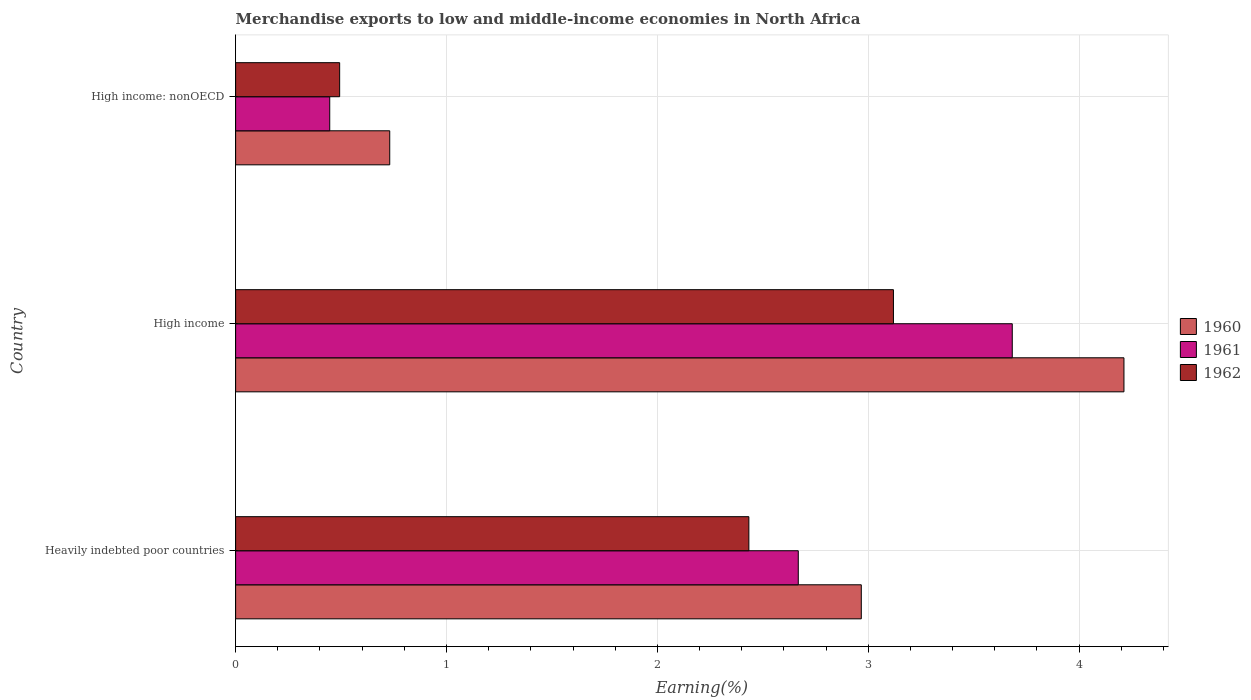How many different coloured bars are there?
Provide a succinct answer. 3. Are the number of bars on each tick of the Y-axis equal?
Offer a terse response. Yes. How many bars are there on the 3rd tick from the top?
Provide a succinct answer. 3. What is the label of the 2nd group of bars from the top?
Provide a short and direct response. High income. In how many cases, is the number of bars for a given country not equal to the number of legend labels?
Provide a succinct answer. 0. What is the percentage of amount earned from merchandise exports in 1962 in High income?
Your answer should be very brief. 3.12. Across all countries, what is the maximum percentage of amount earned from merchandise exports in 1960?
Your response must be concise. 4.21. Across all countries, what is the minimum percentage of amount earned from merchandise exports in 1962?
Your answer should be compact. 0.49. In which country was the percentage of amount earned from merchandise exports in 1960 maximum?
Provide a short and direct response. High income. In which country was the percentage of amount earned from merchandise exports in 1962 minimum?
Keep it short and to the point. High income: nonOECD. What is the total percentage of amount earned from merchandise exports in 1962 in the graph?
Your answer should be compact. 6.05. What is the difference between the percentage of amount earned from merchandise exports in 1960 in Heavily indebted poor countries and that in High income?
Provide a succinct answer. -1.25. What is the difference between the percentage of amount earned from merchandise exports in 1960 in High income and the percentage of amount earned from merchandise exports in 1961 in High income: nonOECD?
Your answer should be very brief. 3.77. What is the average percentage of amount earned from merchandise exports in 1961 per country?
Keep it short and to the point. 2.27. What is the difference between the percentage of amount earned from merchandise exports in 1960 and percentage of amount earned from merchandise exports in 1962 in High income: nonOECD?
Your answer should be very brief. 0.24. In how many countries, is the percentage of amount earned from merchandise exports in 1962 greater than 3.8 %?
Make the answer very short. 0. What is the ratio of the percentage of amount earned from merchandise exports in 1961 in High income to that in High income: nonOECD?
Give a very brief answer. 8.25. Is the percentage of amount earned from merchandise exports in 1961 in High income less than that in High income: nonOECD?
Your answer should be compact. No. What is the difference between the highest and the second highest percentage of amount earned from merchandise exports in 1962?
Your response must be concise. 0.69. What is the difference between the highest and the lowest percentage of amount earned from merchandise exports in 1960?
Provide a short and direct response. 3.48. Is the sum of the percentage of amount earned from merchandise exports in 1960 in High income and High income: nonOECD greater than the maximum percentage of amount earned from merchandise exports in 1962 across all countries?
Provide a succinct answer. Yes. What does the 2nd bar from the bottom in High income represents?
Make the answer very short. 1961. Is it the case that in every country, the sum of the percentage of amount earned from merchandise exports in 1960 and percentage of amount earned from merchandise exports in 1961 is greater than the percentage of amount earned from merchandise exports in 1962?
Give a very brief answer. Yes. How many bars are there?
Ensure brevity in your answer.  9. What is the difference between two consecutive major ticks on the X-axis?
Your answer should be compact. 1. Does the graph contain grids?
Your response must be concise. Yes. Where does the legend appear in the graph?
Keep it short and to the point. Center right. What is the title of the graph?
Provide a short and direct response. Merchandise exports to low and middle-income economies in North Africa. Does "1982" appear as one of the legend labels in the graph?
Give a very brief answer. No. What is the label or title of the X-axis?
Offer a very short reply. Earning(%). What is the label or title of the Y-axis?
Keep it short and to the point. Country. What is the Earning(%) in 1960 in Heavily indebted poor countries?
Provide a short and direct response. 2.97. What is the Earning(%) of 1961 in Heavily indebted poor countries?
Give a very brief answer. 2.67. What is the Earning(%) in 1962 in Heavily indebted poor countries?
Provide a succinct answer. 2.43. What is the Earning(%) of 1960 in High income?
Make the answer very short. 4.21. What is the Earning(%) of 1961 in High income?
Offer a very short reply. 3.68. What is the Earning(%) of 1962 in High income?
Your answer should be compact. 3.12. What is the Earning(%) of 1960 in High income: nonOECD?
Provide a succinct answer. 0.73. What is the Earning(%) of 1961 in High income: nonOECD?
Ensure brevity in your answer.  0.45. What is the Earning(%) in 1962 in High income: nonOECD?
Provide a succinct answer. 0.49. Across all countries, what is the maximum Earning(%) in 1960?
Ensure brevity in your answer.  4.21. Across all countries, what is the maximum Earning(%) in 1961?
Your answer should be compact. 3.68. Across all countries, what is the maximum Earning(%) of 1962?
Your response must be concise. 3.12. Across all countries, what is the minimum Earning(%) in 1960?
Give a very brief answer. 0.73. Across all countries, what is the minimum Earning(%) of 1961?
Ensure brevity in your answer.  0.45. Across all countries, what is the minimum Earning(%) of 1962?
Give a very brief answer. 0.49. What is the total Earning(%) of 1960 in the graph?
Provide a succinct answer. 7.91. What is the total Earning(%) in 1961 in the graph?
Your answer should be compact. 6.8. What is the total Earning(%) in 1962 in the graph?
Provide a short and direct response. 6.05. What is the difference between the Earning(%) of 1960 in Heavily indebted poor countries and that in High income?
Provide a short and direct response. -1.25. What is the difference between the Earning(%) of 1961 in Heavily indebted poor countries and that in High income?
Make the answer very short. -1.01. What is the difference between the Earning(%) of 1962 in Heavily indebted poor countries and that in High income?
Provide a succinct answer. -0.69. What is the difference between the Earning(%) of 1960 in Heavily indebted poor countries and that in High income: nonOECD?
Ensure brevity in your answer.  2.24. What is the difference between the Earning(%) of 1961 in Heavily indebted poor countries and that in High income: nonOECD?
Keep it short and to the point. 2.22. What is the difference between the Earning(%) of 1962 in Heavily indebted poor countries and that in High income: nonOECD?
Give a very brief answer. 1.94. What is the difference between the Earning(%) of 1960 in High income and that in High income: nonOECD?
Your answer should be compact. 3.48. What is the difference between the Earning(%) in 1961 in High income and that in High income: nonOECD?
Your answer should be very brief. 3.24. What is the difference between the Earning(%) of 1962 in High income and that in High income: nonOECD?
Your answer should be very brief. 2.63. What is the difference between the Earning(%) of 1960 in Heavily indebted poor countries and the Earning(%) of 1961 in High income?
Your answer should be very brief. -0.72. What is the difference between the Earning(%) of 1960 in Heavily indebted poor countries and the Earning(%) of 1962 in High income?
Your answer should be compact. -0.15. What is the difference between the Earning(%) of 1961 in Heavily indebted poor countries and the Earning(%) of 1962 in High income?
Ensure brevity in your answer.  -0.45. What is the difference between the Earning(%) of 1960 in Heavily indebted poor countries and the Earning(%) of 1961 in High income: nonOECD?
Your answer should be compact. 2.52. What is the difference between the Earning(%) in 1960 in Heavily indebted poor countries and the Earning(%) in 1962 in High income: nonOECD?
Offer a very short reply. 2.47. What is the difference between the Earning(%) in 1961 in Heavily indebted poor countries and the Earning(%) in 1962 in High income: nonOECD?
Your answer should be very brief. 2.17. What is the difference between the Earning(%) in 1960 in High income and the Earning(%) in 1961 in High income: nonOECD?
Offer a very short reply. 3.77. What is the difference between the Earning(%) in 1960 in High income and the Earning(%) in 1962 in High income: nonOECD?
Your response must be concise. 3.72. What is the difference between the Earning(%) in 1961 in High income and the Earning(%) in 1962 in High income: nonOECD?
Provide a succinct answer. 3.19. What is the average Earning(%) in 1960 per country?
Give a very brief answer. 2.64. What is the average Earning(%) in 1961 per country?
Make the answer very short. 2.27. What is the average Earning(%) in 1962 per country?
Give a very brief answer. 2.02. What is the difference between the Earning(%) of 1960 and Earning(%) of 1961 in Heavily indebted poor countries?
Offer a terse response. 0.3. What is the difference between the Earning(%) of 1960 and Earning(%) of 1962 in Heavily indebted poor countries?
Offer a terse response. 0.53. What is the difference between the Earning(%) of 1961 and Earning(%) of 1962 in Heavily indebted poor countries?
Provide a short and direct response. 0.23. What is the difference between the Earning(%) of 1960 and Earning(%) of 1961 in High income?
Your answer should be compact. 0.53. What is the difference between the Earning(%) in 1960 and Earning(%) in 1962 in High income?
Make the answer very short. 1.09. What is the difference between the Earning(%) in 1961 and Earning(%) in 1962 in High income?
Make the answer very short. 0.56. What is the difference between the Earning(%) in 1960 and Earning(%) in 1961 in High income: nonOECD?
Ensure brevity in your answer.  0.28. What is the difference between the Earning(%) in 1960 and Earning(%) in 1962 in High income: nonOECD?
Ensure brevity in your answer.  0.24. What is the difference between the Earning(%) of 1961 and Earning(%) of 1962 in High income: nonOECD?
Give a very brief answer. -0.05. What is the ratio of the Earning(%) in 1960 in Heavily indebted poor countries to that in High income?
Provide a short and direct response. 0.7. What is the ratio of the Earning(%) of 1961 in Heavily indebted poor countries to that in High income?
Your answer should be very brief. 0.72. What is the ratio of the Earning(%) of 1962 in Heavily indebted poor countries to that in High income?
Give a very brief answer. 0.78. What is the ratio of the Earning(%) in 1960 in Heavily indebted poor countries to that in High income: nonOECD?
Keep it short and to the point. 4.06. What is the ratio of the Earning(%) in 1961 in Heavily indebted poor countries to that in High income: nonOECD?
Your response must be concise. 5.98. What is the ratio of the Earning(%) of 1962 in Heavily indebted poor countries to that in High income: nonOECD?
Give a very brief answer. 4.93. What is the ratio of the Earning(%) of 1960 in High income to that in High income: nonOECD?
Provide a short and direct response. 5.76. What is the ratio of the Earning(%) in 1961 in High income to that in High income: nonOECD?
Keep it short and to the point. 8.25. What is the ratio of the Earning(%) in 1962 in High income to that in High income: nonOECD?
Provide a succinct answer. 6.32. What is the difference between the highest and the second highest Earning(%) of 1960?
Provide a short and direct response. 1.25. What is the difference between the highest and the second highest Earning(%) of 1961?
Give a very brief answer. 1.01. What is the difference between the highest and the second highest Earning(%) of 1962?
Offer a very short reply. 0.69. What is the difference between the highest and the lowest Earning(%) of 1960?
Your answer should be compact. 3.48. What is the difference between the highest and the lowest Earning(%) in 1961?
Your response must be concise. 3.24. What is the difference between the highest and the lowest Earning(%) in 1962?
Ensure brevity in your answer.  2.63. 